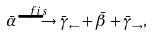Convert formula to latex. <formula><loc_0><loc_0><loc_500><loc_500>\bar { \alpha } \stackrel { f i s } { \longrightarrow } \bar { \gamma } _ { \leftarrow } + \bar { \beta } + \bar { \gamma } _ { \rightarrow } ,</formula> 